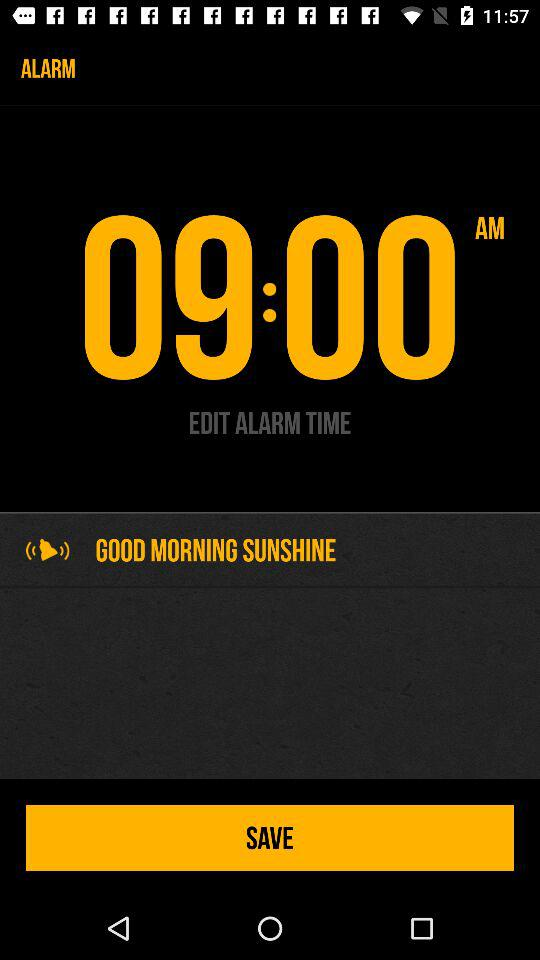How many more minutes are there until 10:00 than 09:00?
Answer the question using a single word or phrase. 60 